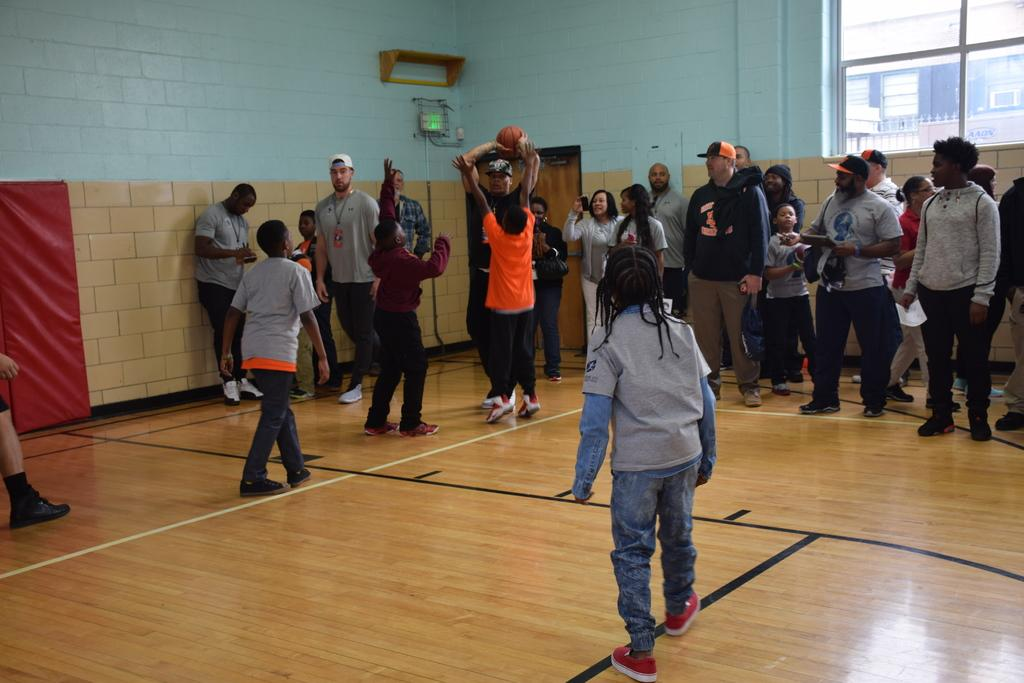What is happening in the image? There are people standing in the image. What object can be seen near the people? There is a basketball in the image. What can be seen in the background of the image? There is a wall in the background of the image. What type of structure is present in the image? There is a glass window in the image. What type of magic is being performed with the basketball in the image? There is no magic being performed in the image; it simply shows people standing near a basketball. What is the zinc content of the glass window in the image? There is no information about the zinc content of the glass window in the image, as it is not relevant to the image's content. 